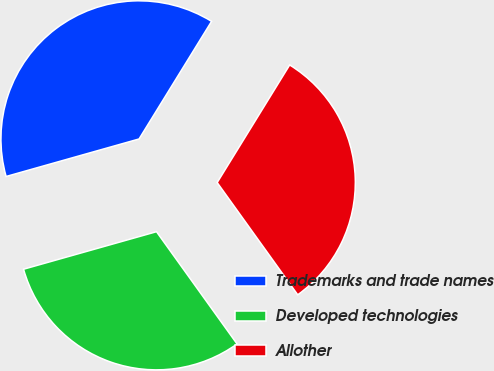Convert chart. <chart><loc_0><loc_0><loc_500><loc_500><pie_chart><fcel>Trademarks and trade names<fcel>Developed technologies<fcel>Allother<nl><fcel>38.17%<fcel>30.53%<fcel>31.3%<nl></chart> 